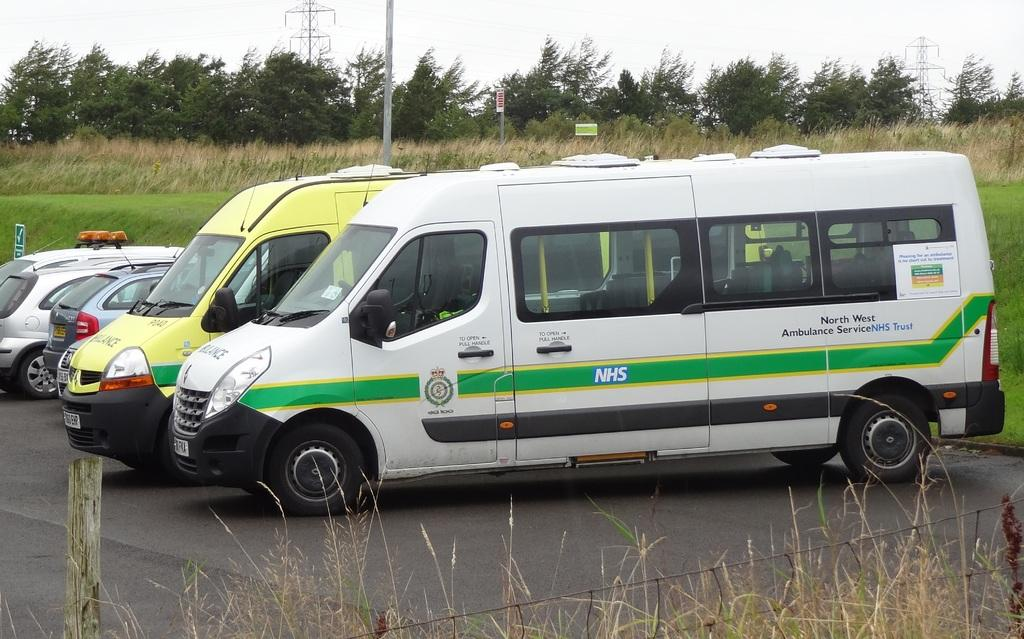<image>
Relay a brief, clear account of the picture shown. Two vans and two cars are parked, one van bearing the letters NHS in a green stripe on its side. 